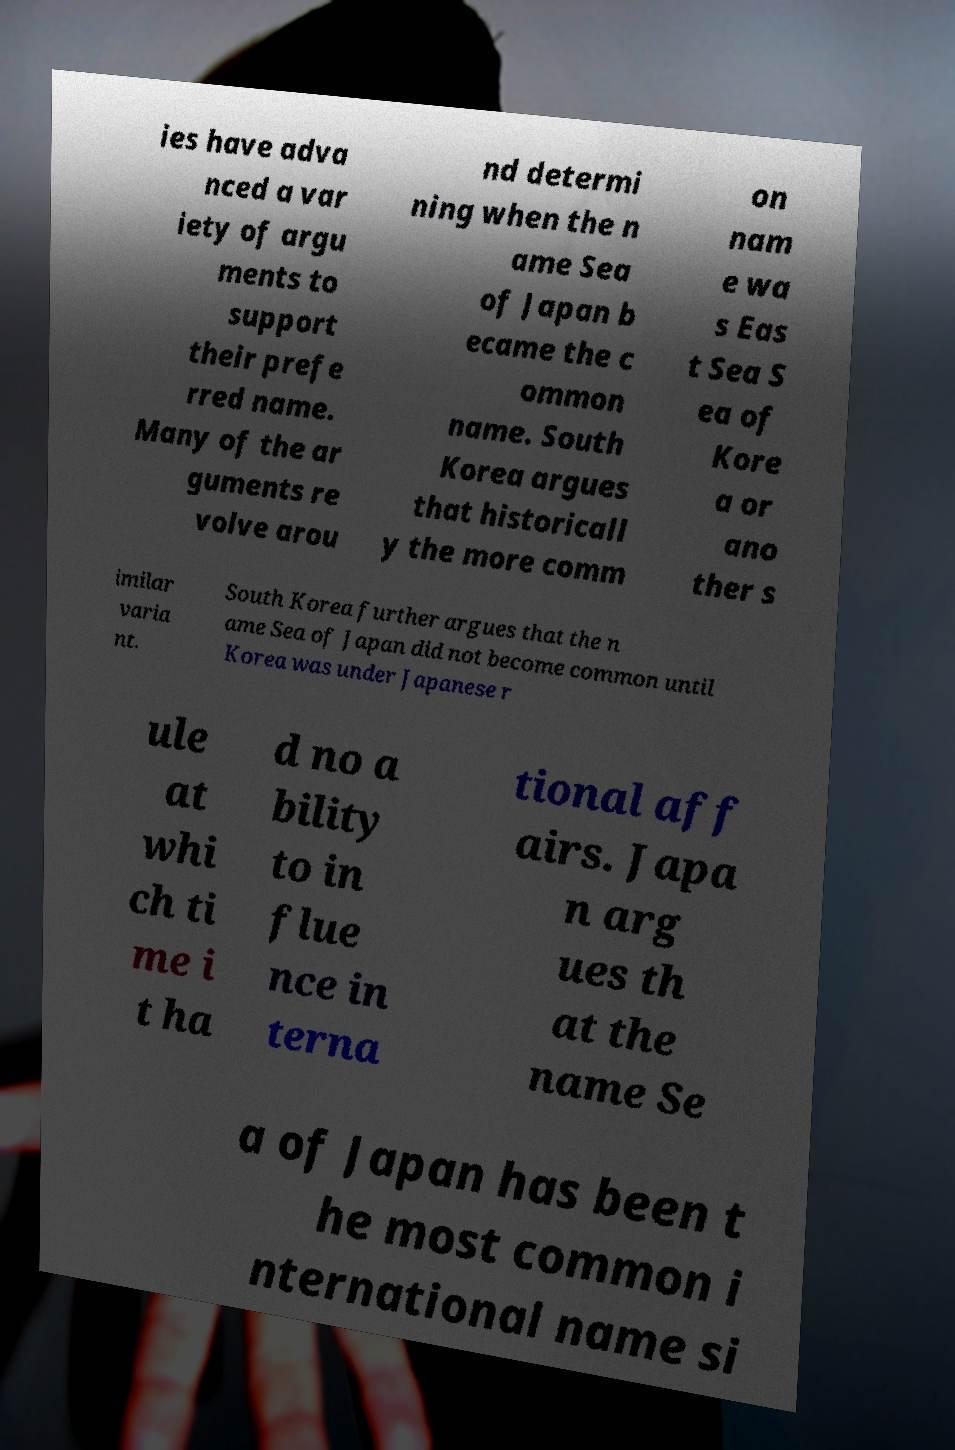For documentation purposes, I need the text within this image transcribed. Could you provide that? ies have adva nced a var iety of argu ments to support their prefe rred name. Many of the ar guments re volve arou nd determi ning when the n ame Sea of Japan b ecame the c ommon name. South Korea argues that historicall y the more comm on nam e wa s Eas t Sea S ea of Kore a or ano ther s imilar varia nt. South Korea further argues that the n ame Sea of Japan did not become common until Korea was under Japanese r ule at whi ch ti me i t ha d no a bility to in flue nce in terna tional aff airs. Japa n arg ues th at the name Se a of Japan has been t he most common i nternational name si 